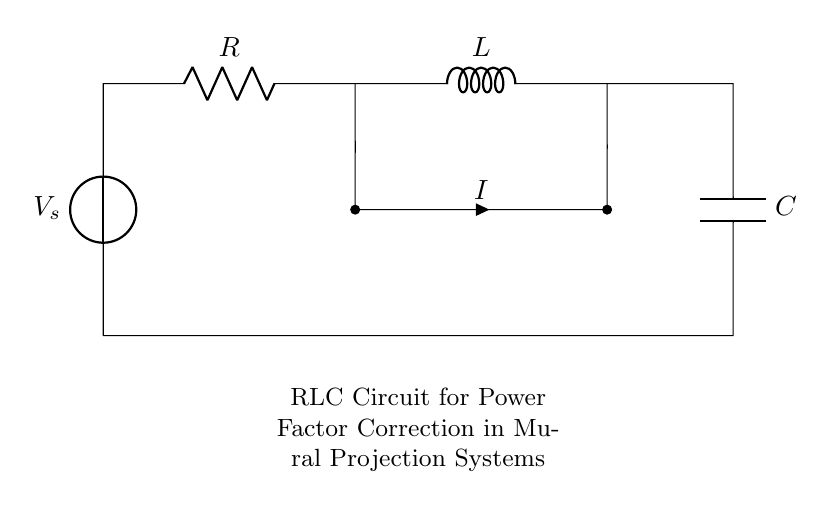What is the type of voltage source in this circuit? The diagram shows a direct voltage source symbol labeled as V_s, indicating it provides a constant voltage to the circuit.
Answer: direct What is the passive component used for resistance? The resistor symbol is indicated in the diagram with a label R, which represents the component that limits the current flow.
Answer: R What is connected in series with the resistor? The inductor labeled L is connected immediately after the resistor, indicating it is in series with it.
Answer: L What is the total current flowing through the circuit? The circuit shows a current label i at the short connection between the resistor and inductor, implying a singular current flows through those components.
Answer: I Which component is responsible for power factor correction? In this circuit, the capacitor labeled C is specifically used for power factor correction by compensating for the inductive reactance of the inductor L.
Answer: C How do you find the impedance of this RLC circuit? The total impedance Z of a series RLC circuit is found by combining the resistance R with the reactance of the inductor and capacitor through the formula Z = √(R² + (X_L - X_C)²), where X_L is the inductive reactance and X_C is the capacitive reactance.
Answer: Z 